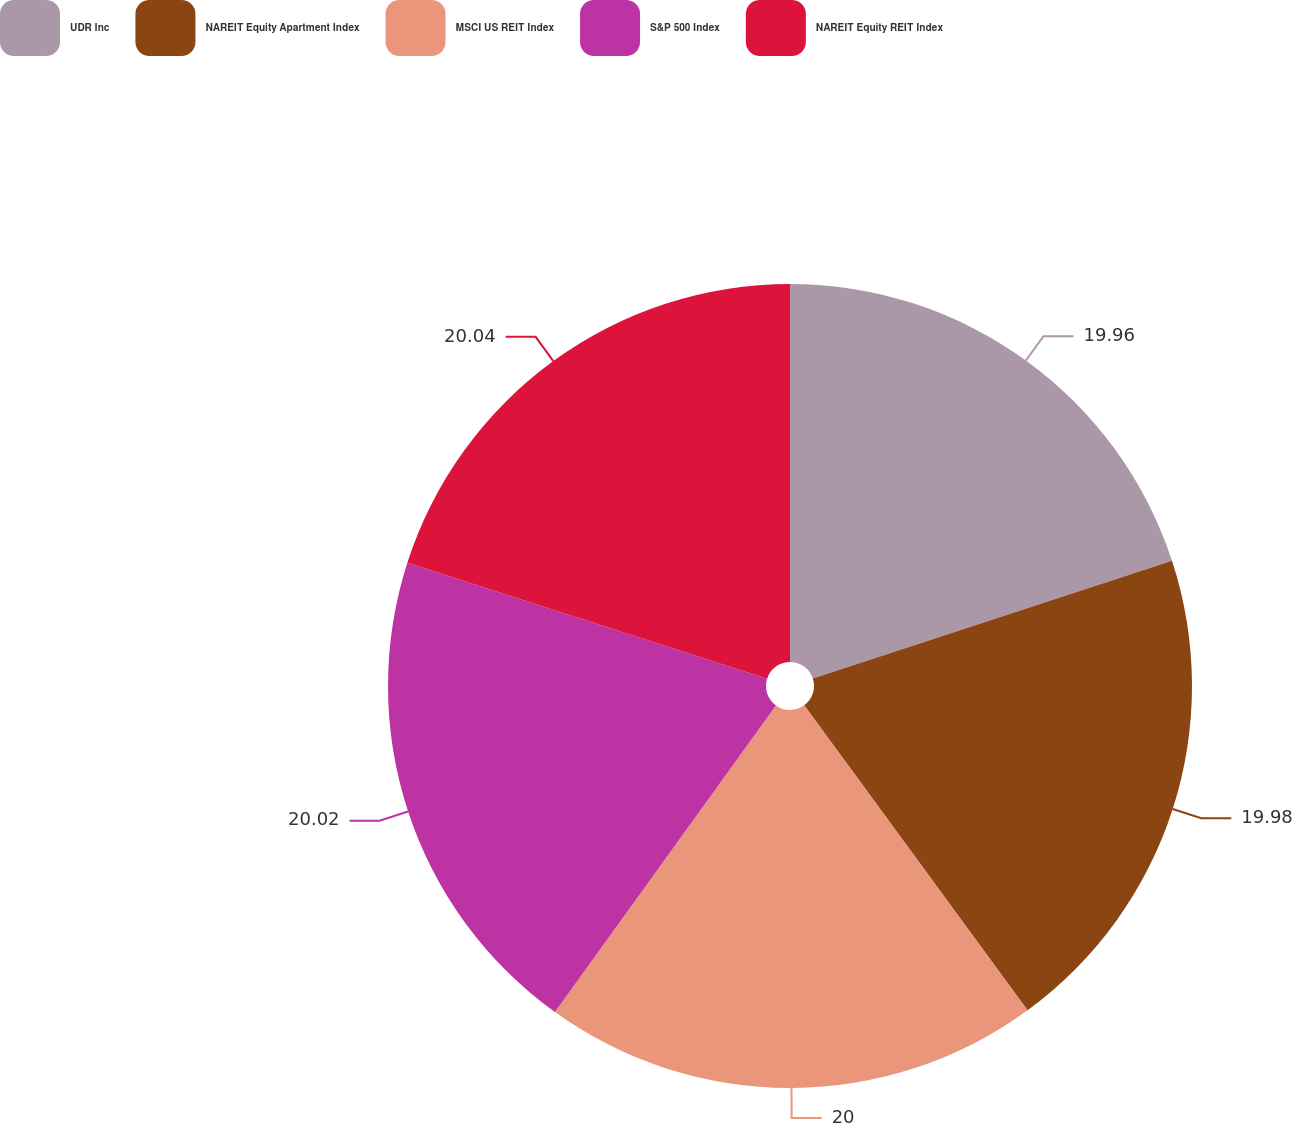Convert chart to OTSL. <chart><loc_0><loc_0><loc_500><loc_500><pie_chart><fcel>UDR Inc<fcel>NAREIT Equity Apartment Index<fcel>MSCI US REIT Index<fcel>S&P 500 Index<fcel>NAREIT Equity REIT Index<nl><fcel>19.96%<fcel>19.98%<fcel>20.0%<fcel>20.02%<fcel>20.04%<nl></chart> 